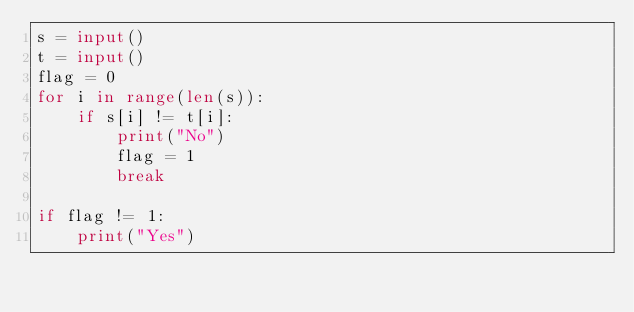Convert code to text. <code><loc_0><loc_0><loc_500><loc_500><_Python_>s = input()
t = input()
flag = 0
for i in range(len(s)):
    if s[i] != t[i]:
        print("No")
        flag = 1
        break

if flag != 1:
    print("Yes")</code> 